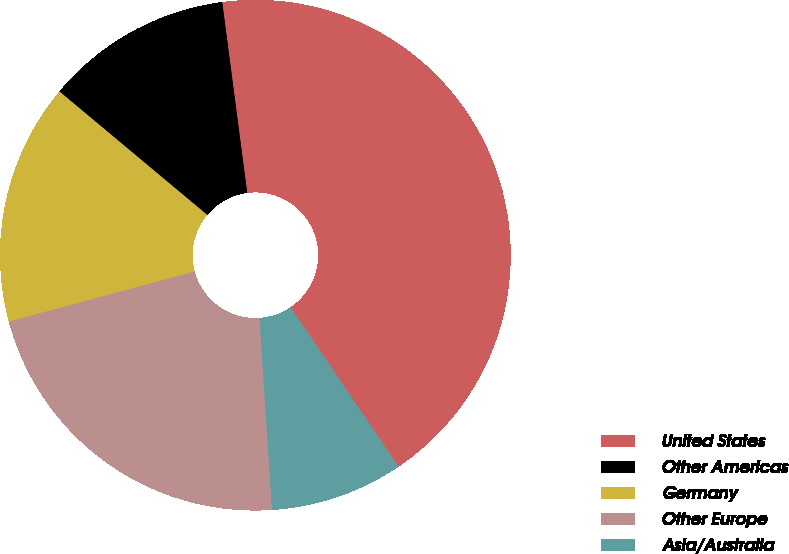Convert chart to OTSL. <chart><loc_0><loc_0><loc_500><loc_500><pie_chart><fcel>United States<fcel>Other Americas<fcel>Germany<fcel>Other Europe<fcel>Asia/Australia<nl><fcel>42.6%<fcel>11.85%<fcel>15.27%<fcel>21.85%<fcel>8.43%<nl></chart> 